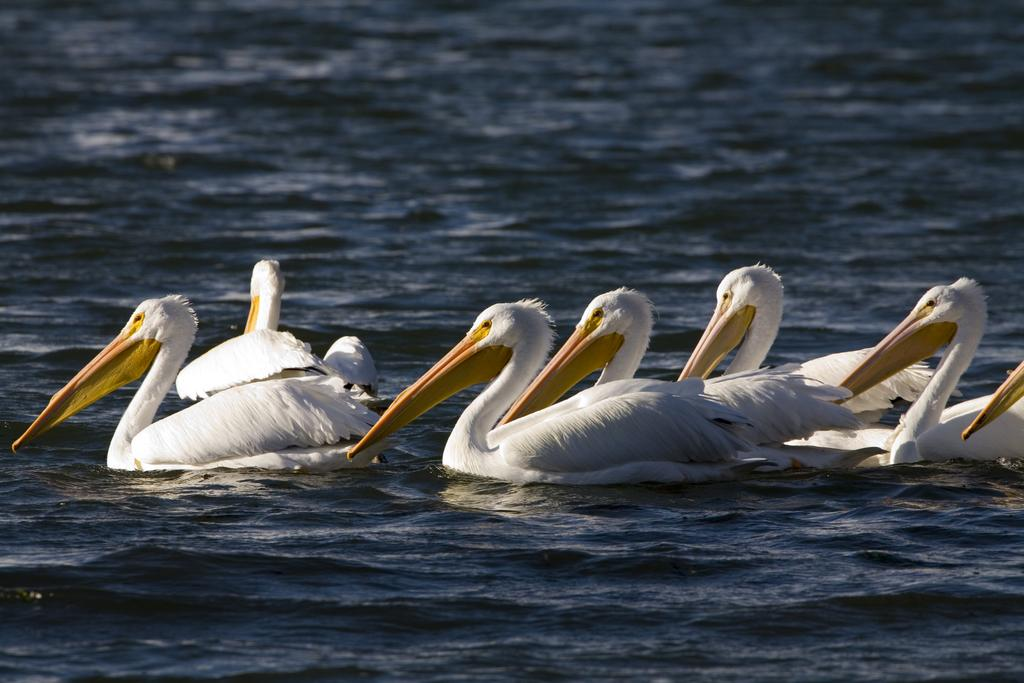What type of animals are in the image? There are white pelicans in the image. Where are the white pelicans located? The white pelicans are in the water. What type of skin treatment is being applied to the white pelicans in the image? There is no indication of any skin treatment being applied to the white pelicans in the image; they are simply in the water. 